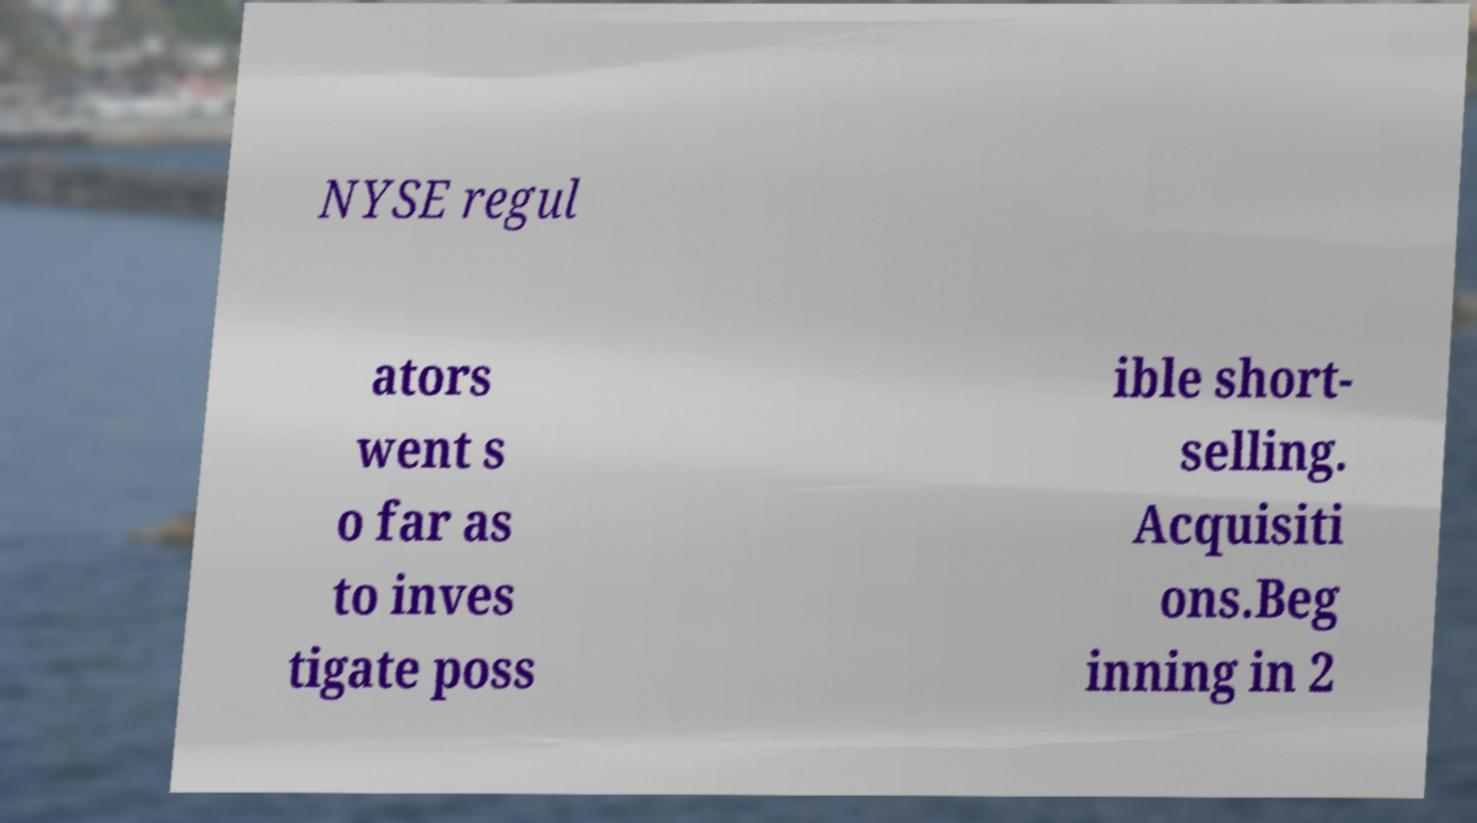Can you read and provide the text displayed in the image?This photo seems to have some interesting text. Can you extract and type it out for me? NYSE regul ators went s o far as to inves tigate poss ible short- selling. Acquisiti ons.Beg inning in 2 